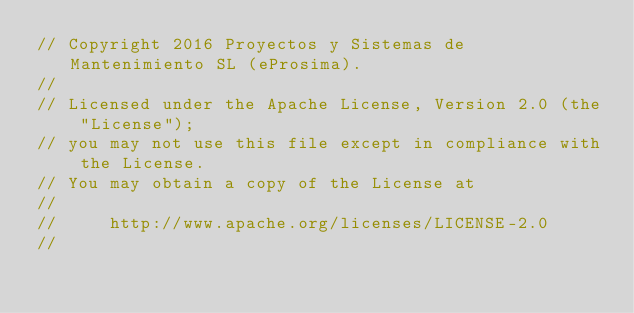<code> <loc_0><loc_0><loc_500><loc_500><_C_>// Copyright 2016 Proyectos y Sistemas de Mantenimiento SL (eProsima).
//
// Licensed under the Apache License, Version 2.0 (the "License");
// you may not use this file except in compliance with the License.
// You may obtain a copy of the License at
//
//     http://www.apache.org/licenses/LICENSE-2.0
//</code> 